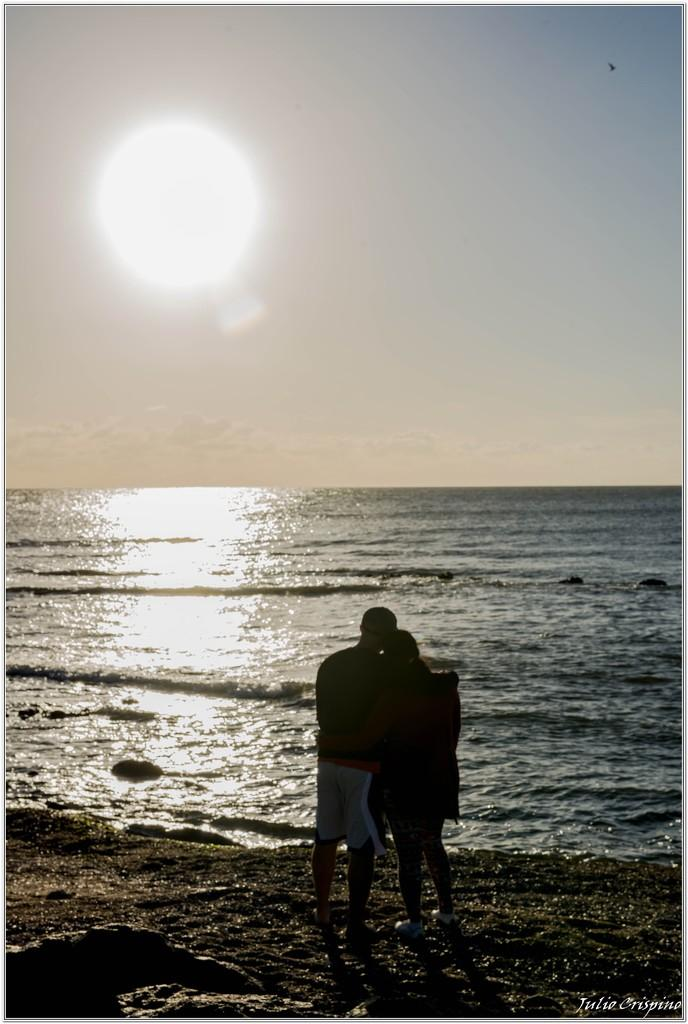How many people are in the image? There are two persons standing in the image. What is the surface on which the persons are standing? The persons are standing on the ground. What natural element can be seen in the image? There is water visible in the image. What celestial body is visible in the background? The sun is visible in the background. What else can be seen in the background of the image? The sky is visible in the background. What type of organization is depicted in the image? There is no organization depicted in the image; it features two persons standing near water with the sun and sky visible in the background. How many crows are visible in the image? There are no crows present in the image. 